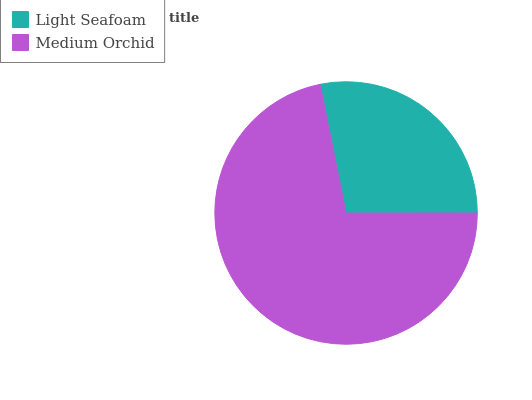Is Light Seafoam the minimum?
Answer yes or no. Yes. Is Medium Orchid the maximum?
Answer yes or no. Yes. Is Medium Orchid the minimum?
Answer yes or no. No. Is Medium Orchid greater than Light Seafoam?
Answer yes or no. Yes. Is Light Seafoam less than Medium Orchid?
Answer yes or no. Yes. Is Light Seafoam greater than Medium Orchid?
Answer yes or no. No. Is Medium Orchid less than Light Seafoam?
Answer yes or no. No. Is Medium Orchid the high median?
Answer yes or no. Yes. Is Light Seafoam the low median?
Answer yes or no. Yes. Is Light Seafoam the high median?
Answer yes or no. No. Is Medium Orchid the low median?
Answer yes or no. No. 